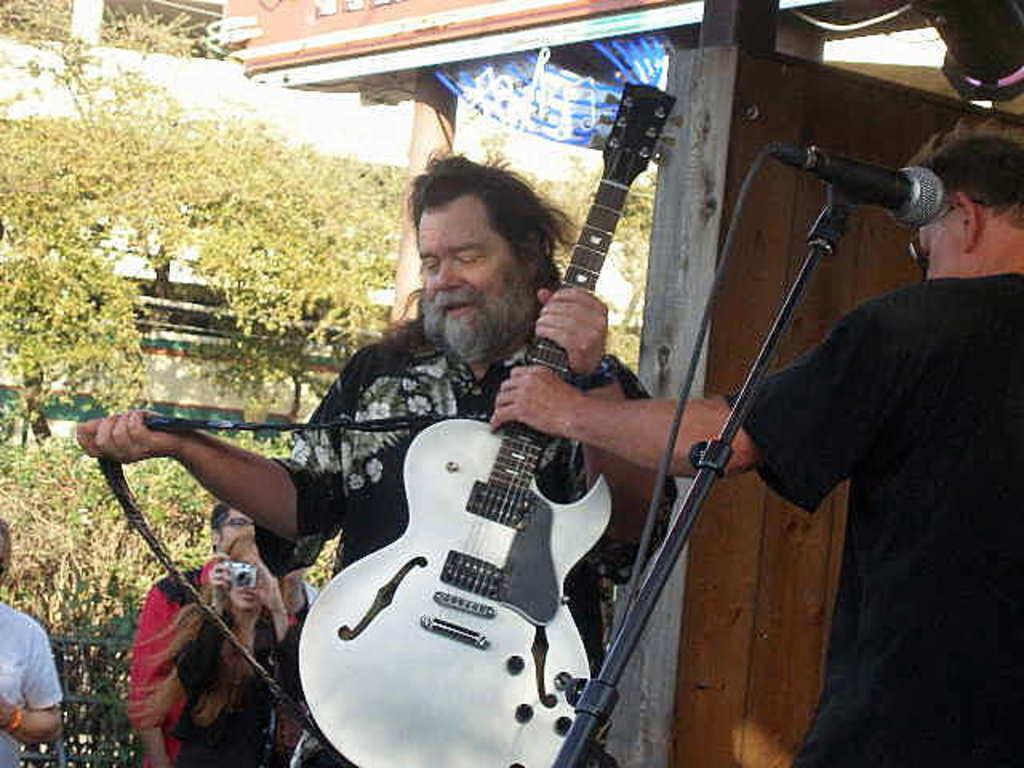Can you describe this image briefly? In this image I can see few people where one is holding a guitar and here one is holding a camera. I can also see a mic and number of trees. 